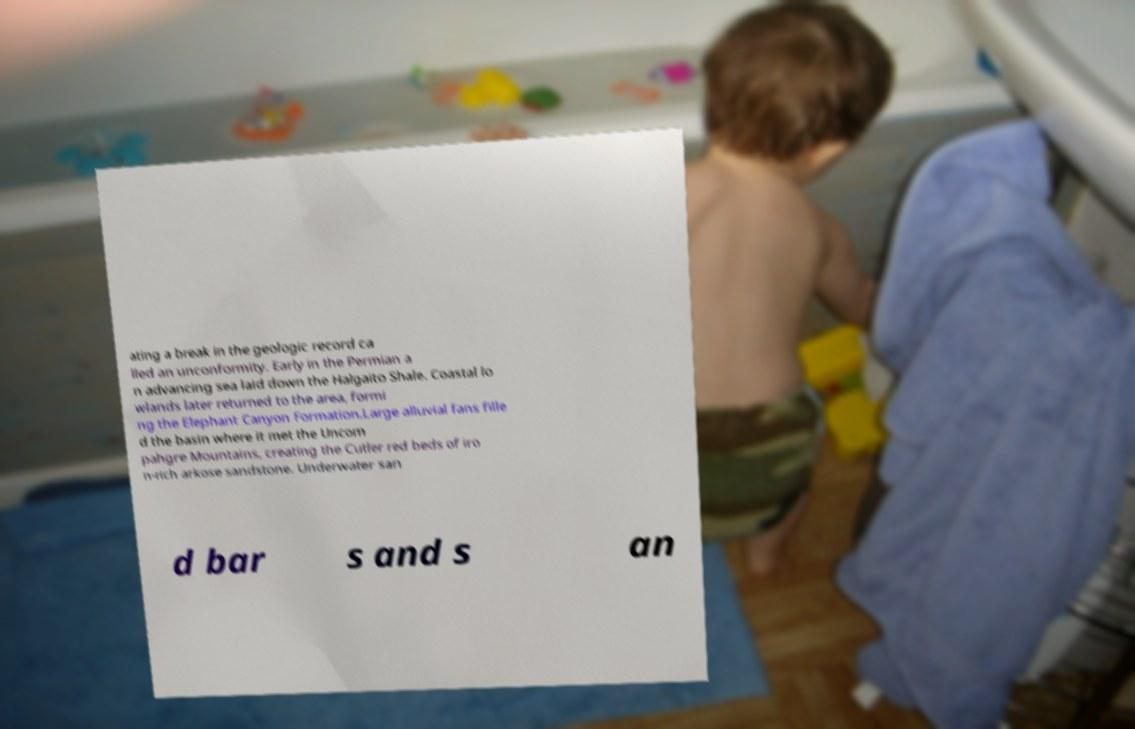Please read and relay the text visible in this image. What does it say? ating a break in the geologic record ca lled an unconformity. Early in the Permian a n advancing sea laid down the Halgaito Shale. Coastal lo wlands later returned to the area, formi ng the Elephant Canyon Formation.Large alluvial fans fille d the basin where it met the Uncom pahgre Mountains, creating the Cutler red beds of iro n-rich arkose sandstone. Underwater san d bar s and s an 